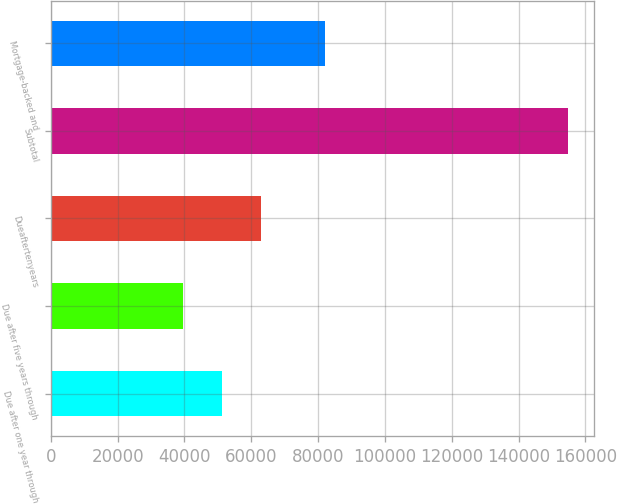<chart> <loc_0><loc_0><loc_500><loc_500><bar_chart><fcel>Due after one year through<fcel>Due after five years through<fcel>Dueaftertenyears<fcel>Subtotal<fcel>Mortgage-backed and<nl><fcel>51098.7<fcel>39571<fcel>63023<fcel>154848<fcel>81920<nl></chart> 